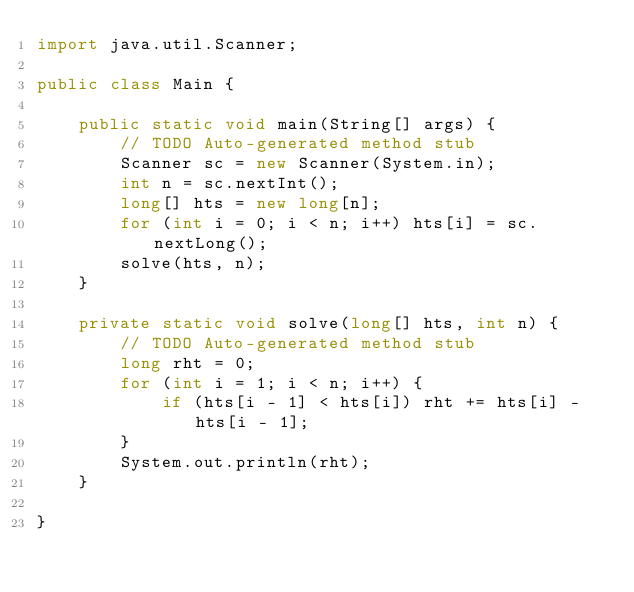<code> <loc_0><loc_0><loc_500><loc_500><_Java_>import java.util.Scanner;

public class Main {

	public static void main(String[] args) {
		// TODO Auto-generated method stub
		Scanner sc = new Scanner(System.in);
		int n = sc.nextInt();
		long[] hts = new long[n];
		for (int i = 0; i < n; i++) hts[i] = sc.nextLong();
		solve(hts, n);
	}

	private static void solve(long[] hts, int n) {
		// TODO Auto-generated method stub
		long rht = 0;
		for (int i = 1; i < n; i++) {
			if (hts[i - 1] < hts[i]) rht += hts[i] - hts[i - 1];
		}
		System.out.println(rht);
	}

}
</code> 